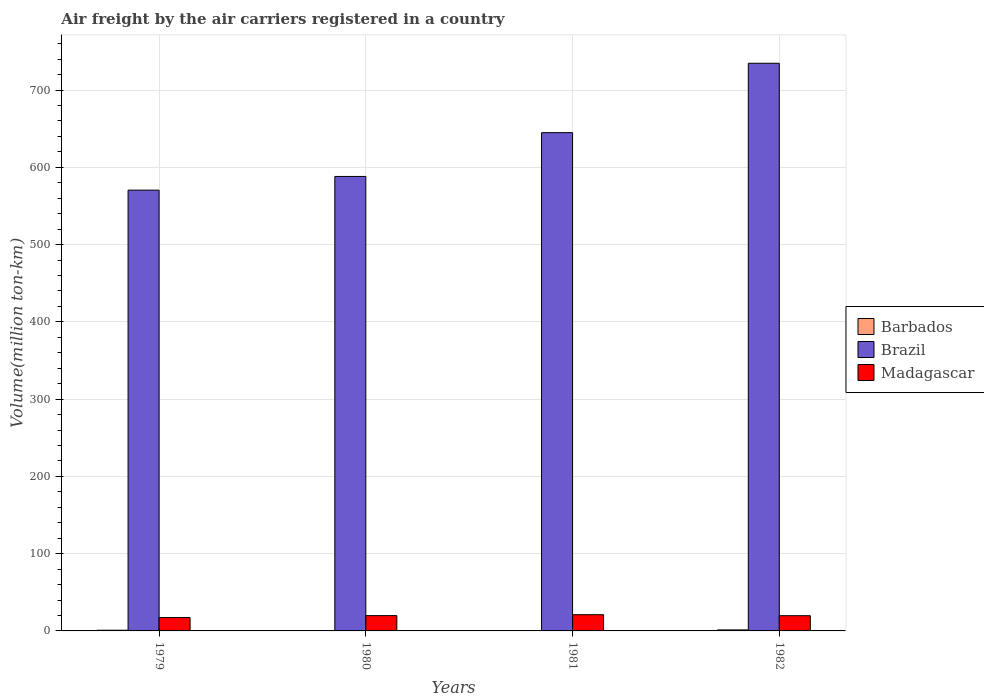How many different coloured bars are there?
Give a very brief answer. 3. How many groups of bars are there?
Your response must be concise. 4. Are the number of bars on each tick of the X-axis equal?
Make the answer very short. Yes. How many bars are there on the 4th tick from the right?
Provide a short and direct response. 3. In how many cases, is the number of bars for a given year not equal to the number of legend labels?
Offer a very short reply. 0. What is the volume of the air carriers in Madagascar in 1979?
Ensure brevity in your answer.  17.3. Across all years, what is the maximum volume of the air carriers in Barbados?
Keep it short and to the point. 1.3. Across all years, what is the minimum volume of the air carriers in Barbados?
Provide a succinct answer. 0.3. In which year was the volume of the air carriers in Barbados maximum?
Make the answer very short. 1982. In which year was the volume of the air carriers in Madagascar minimum?
Ensure brevity in your answer.  1979. What is the total volume of the air carriers in Madagascar in the graph?
Keep it short and to the point. 77.8. What is the difference between the volume of the air carriers in Barbados in 1980 and that in 1982?
Your response must be concise. -0.8. What is the difference between the volume of the air carriers in Barbados in 1982 and the volume of the air carriers in Brazil in 1979?
Your answer should be compact. -569.2. What is the average volume of the air carriers in Brazil per year?
Make the answer very short. 634.58. In the year 1981, what is the difference between the volume of the air carriers in Brazil and volume of the air carriers in Madagascar?
Your response must be concise. 623.9. In how many years, is the volume of the air carriers in Barbados greater than 340 million ton-km?
Ensure brevity in your answer.  0. What is the ratio of the volume of the air carriers in Madagascar in 1981 to that in 1982?
Your response must be concise. 1.07. Is the volume of the air carriers in Madagascar in 1979 less than that in 1981?
Provide a short and direct response. Yes. What is the difference between the highest and the second highest volume of the air carriers in Brazil?
Keep it short and to the point. 89.8. What is the difference between the highest and the lowest volume of the air carriers in Barbados?
Provide a succinct answer. 1. In how many years, is the volume of the air carriers in Madagascar greater than the average volume of the air carriers in Madagascar taken over all years?
Ensure brevity in your answer.  3. Is the sum of the volume of the air carriers in Madagascar in 1979 and 1980 greater than the maximum volume of the air carriers in Brazil across all years?
Your answer should be compact. No. What does the 1st bar from the left in 1980 represents?
Make the answer very short. Barbados. Is it the case that in every year, the sum of the volume of the air carriers in Brazil and volume of the air carriers in Madagascar is greater than the volume of the air carriers in Barbados?
Provide a succinct answer. Yes. Are all the bars in the graph horizontal?
Offer a very short reply. No. Are the values on the major ticks of Y-axis written in scientific E-notation?
Provide a short and direct response. No. Where does the legend appear in the graph?
Your answer should be very brief. Center right. What is the title of the graph?
Provide a short and direct response. Air freight by the air carriers registered in a country. What is the label or title of the X-axis?
Provide a succinct answer. Years. What is the label or title of the Y-axis?
Your response must be concise. Volume(million ton-km). What is the Volume(million ton-km) of Barbados in 1979?
Make the answer very short. 0.9. What is the Volume(million ton-km) of Brazil in 1979?
Ensure brevity in your answer.  570.5. What is the Volume(million ton-km) in Madagascar in 1979?
Provide a short and direct response. 17.3. What is the Volume(million ton-km) of Brazil in 1980?
Provide a succinct answer. 588.2. What is the Volume(million ton-km) of Madagascar in 1980?
Give a very brief answer. 19.8. What is the Volume(million ton-km) of Barbados in 1981?
Your answer should be very brief. 0.3. What is the Volume(million ton-km) of Brazil in 1981?
Your response must be concise. 644.9. What is the Volume(million ton-km) in Barbados in 1982?
Your answer should be compact. 1.3. What is the Volume(million ton-km) in Brazil in 1982?
Your answer should be very brief. 734.7. What is the Volume(million ton-km) of Madagascar in 1982?
Offer a terse response. 19.7. Across all years, what is the maximum Volume(million ton-km) in Barbados?
Provide a succinct answer. 1.3. Across all years, what is the maximum Volume(million ton-km) in Brazil?
Give a very brief answer. 734.7. Across all years, what is the minimum Volume(million ton-km) of Barbados?
Keep it short and to the point. 0.3. Across all years, what is the minimum Volume(million ton-km) of Brazil?
Keep it short and to the point. 570.5. Across all years, what is the minimum Volume(million ton-km) of Madagascar?
Make the answer very short. 17.3. What is the total Volume(million ton-km) in Brazil in the graph?
Provide a short and direct response. 2538.3. What is the total Volume(million ton-km) in Madagascar in the graph?
Make the answer very short. 77.8. What is the difference between the Volume(million ton-km) in Barbados in 1979 and that in 1980?
Offer a very short reply. 0.4. What is the difference between the Volume(million ton-km) of Brazil in 1979 and that in 1980?
Your answer should be very brief. -17.7. What is the difference between the Volume(million ton-km) of Barbados in 1979 and that in 1981?
Make the answer very short. 0.6. What is the difference between the Volume(million ton-km) in Brazil in 1979 and that in 1981?
Give a very brief answer. -74.4. What is the difference between the Volume(million ton-km) of Brazil in 1979 and that in 1982?
Ensure brevity in your answer.  -164.2. What is the difference between the Volume(million ton-km) of Barbados in 1980 and that in 1981?
Give a very brief answer. 0.2. What is the difference between the Volume(million ton-km) in Brazil in 1980 and that in 1981?
Offer a terse response. -56.7. What is the difference between the Volume(million ton-km) of Madagascar in 1980 and that in 1981?
Your answer should be very brief. -1.2. What is the difference between the Volume(million ton-km) of Barbados in 1980 and that in 1982?
Your response must be concise. -0.8. What is the difference between the Volume(million ton-km) in Brazil in 1980 and that in 1982?
Your answer should be compact. -146.5. What is the difference between the Volume(million ton-km) in Madagascar in 1980 and that in 1982?
Keep it short and to the point. 0.1. What is the difference between the Volume(million ton-km) in Barbados in 1981 and that in 1982?
Your answer should be very brief. -1. What is the difference between the Volume(million ton-km) of Brazil in 1981 and that in 1982?
Your answer should be very brief. -89.8. What is the difference between the Volume(million ton-km) in Madagascar in 1981 and that in 1982?
Keep it short and to the point. 1.3. What is the difference between the Volume(million ton-km) in Barbados in 1979 and the Volume(million ton-km) in Brazil in 1980?
Your response must be concise. -587.3. What is the difference between the Volume(million ton-km) of Barbados in 1979 and the Volume(million ton-km) of Madagascar in 1980?
Provide a short and direct response. -18.9. What is the difference between the Volume(million ton-km) of Brazil in 1979 and the Volume(million ton-km) of Madagascar in 1980?
Ensure brevity in your answer.  550.7. What is the difference between the Volume(million ton-km) in Barbados in 1979 and the Volume(million ton-km) in Brazil in 1981?
Ensure brevity in your answer.  -644. What is the difference between the Volume(million ton-km) of Barbados in 1979 and the Volume(million ton-km) of Madagascar in 1981?
Your answer should be very brief. -20.1. What is the difference between the Volume(million ton-km) in Brazil in 1979 and the Volume(million ton-km) in Madagascar in 1981?
Your answer should be very brief. 549.5. What is the difference between the Volume(million ton-km) of Barbados in 1979 and the Volume(million ton-km) of Brazil in 1982?
Ensure brevity in your answer.  -733.8. What is the difference between the Volume(million ton-km) in Barbados in 1979 and the Volume(million ton-km) in Madagascar in 1982?
Make the answer very short. -18.8. What is the difference between the Volume(million ton-km) in Brazil in 1979 and the Volume(million ton-km) in Madagascar in 1982?
Give a very brief answer. 550.8. What is the difference between the Volume(million ton-km) in Barbados in 1980 and the Volume(million ton-km) in Brazil in 1981?
Your answer should be compact. -644.4. What is the difference between the Volume(million ton-km) of Barbados in 1980 and the Volume(million ton-km) of Madagascar in 1981?
Your answer should be very brief. -20.5. What is the difference between the Volume(million ton-km) of Brazil in 1980 and the Volume(million ton-km) of Madagascar in 1981?
Your response must be concise. 567.2. What is the difference between the Volume(million ton-km) in Barbados in 1980 and the Volume(million ton-km) in Brazil in 1982?
Your answer should be compact. -734.2. What is the difference between the Volume(million ton-km) in Barbados in 1980 and the Volume(million ton-km) in Madagascar in 1982?
Make the answer very short. -19.2. What is the difference between the Volume(million ton-km) in Brazil in 1980 and the Volume(million ton-km) in Madagascar in 1982?
Offer a terse response. 568.5. What is the difference between the Volume(million ton-km) in Barbados in 1981 and the Volume(million ton-km) in Brazil in 1982?
Give a very brief answer. -734.4. What is the difference between the Volume(million ton-km) of Barbados in 1981 and the Volume(million ton-km) of Madagascar in 1982?
Offer a very short reply. -19.4. What is the difference between the Volume(million ton-km) of Brazil in 1981 and the Volume(million ton-km) of Madagascar in 1982?
Offer a terse response. 625.2. What is the average Volume(million ton-km) in Barbados per year?
Provide a short and direct response. 0.75. What is the average Volume(million ton-km) of Brazil per year?
Give a very brief answer. 634.58. What is the average Volume(million ton-km) of Madagascar per year?
Make the answer very short. 19.45. In the year 1979, what is the difference between the Volume(million ton-km) in Barbados and Volume(million ton-km) in Brazil?
Ensure brevity in your answer.  -569.6. In the year 1979, what is the difference between the Volume(million ton-km) in Barbados and Volume(million ton-km) in Madagascar?
Your answer should be very brief. -16.4. In the year 1979, what is the difference between the Volume(million ton-km) of Brazil and Volume(million ton-km) of Madagascar?
Offer a very short reply. 553.2. In the year 1980, what is the difference between the Volume(million ton-km) in Barbados and Volume(million ton-km) in Brazil?
Offer a very short reply. -587.7. In the year 1980, what is the difference between the Volume(million ton-km) in Barbados and Volume(million ton-km) in Madagascar?
Your answer should be very brief. -19.3. In the year 1980, what is the difference between the Volume(million ton-km) of Brazil and Volume(million ton-km) of Madagascar?
Make the answer very short. 568.4. In the year 1981, what is the difference between the Volume(million ton-km) of Barbados and Volume(million ton-km) of Brazil?
Offer a terse response. -644.6. In the year 1981, what is the difference between the Volume(million ton-km) of Barbados and Volume(million ton-km) of Madagascar?
Your response must be concise. -20.7. In the year 1981, what is the difference between the Volume(million ton-km) of Brazil and Volume(million ton-km) of Madagascar?
Keep it short and to the point. 623.9. In the year 1982, what is the difference between the Volume(million ton-km) of Barbados and Volume(million ton-km) of Brazil?
Offer a very short reply. -733.4. In the year 1982, what is the difference between the Volume(million ton-km) of Barbados and Volume(million ton-km) of Madagascar?
Provide a succinct answer. -18.4. In the year 1982, what is the difference between the Volume(million ton-km) in Brazil and Volume(million ton-km) in Madagascar?
Provide a short and direct response. 715. What is the ratio of the Volume(million ton-km) of Barbados in 1979 to that in 1980?
Ensure brevity in your answer.  1.8. What is the ratio of the Volume(million ton-km) of Brazil in 1979 to that in 1980?
Your answer should be compact. 0.97. What is the ratio of the Volume(million ton-km) in Madagascar in 1979 to that in 1980?
Your response must be concise. 0.87. What is the ratio of the Volume(million ton-km) of Brazil in 1979 to that in 1981?
Your answer should be compact. 0.88. What is the ratio of the Volume(million ton-km) of Madagascar in 1979 to that in 1981?
Your response must be concise. 0.82. What is the ratio of the Volume(million ton-km) in Barbados in 1979 to that in 1982?
Keep it short and to the point. 0.69. What is the ratio of the Volume(million ton-km) of Brazil in 1979 to that in 1982?
Make the answer very short. 0.78. What is the ratio of the Volume(million ton-km) of Madagascar in 1979 to that in 1982?
Offer a terse response. 0.88. What is the ratio of the Volume(million ton-km) of Brazil in 1980 to that in 1981?
Offer a terse response. 0.91. What is the ratio of the Volume(million ton-km) in Madagascar in 1980 to that in 1981?
Your response must be concise. 0.94. What is the ratio of the Volume(million ton-km) in Barbados in 1980 to that in 1982?
Keep it short and to the point. 0.38. What is the ratio of the Volume(million ton-km) in Brazil in 1980 to that in 1982?
Ensure brevity in your answer.  0.8. What is the ratio of the Volume(million ton-km) in Madagascar in 1980 to that in 1982?
Keep it short and to the point. 1.01. What is the ratio of the Volume(million ton-km) in Barbados in 1981 to that in 1982?
Give a very brief answer. 0.23. What is the ratio of the Volume(million ton-km) of Brazil in 1981 to that in 1982?
Your answer should be very brief. 0.88. What is the ratio of the Volume(million ton-km) of Madagascar in 1981 to that in 1982?
Offer a terse response. 1.07. What is the difference between the highest and the second highest Volume(million ton-km) of Brazil?
Your response must be concise. 89.8. What is the difference between the highest and the lowest Volume(million ton-km) of Barbados?
Provide a succinct answer. 1. What is the difference between the highest and the lowest Volume(million ton-km) in Brazil?
Give a very brief answer. 164.2. 